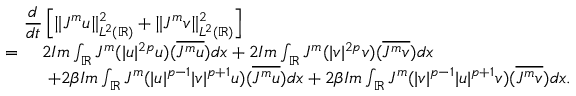<formula> <loc_0><loc_0><loc_500><loc_500>\begin{array} { r l } { { \frac { d } { d t } \left [ \| J ^ { m } u \| _ { L ^ { 2 } ( \mathbb { R } ) } ^ { 2 } + \| J ^ { m } v \| _ { L ^ { 2 } ( \mathbb { R } ) } ^ { 2 } \right ] } } \\ { = \ } & { 2 I m \int _ { \mathbb { R } } J ^ { m } ( | u | ^ { 2 p } u ) ( \overline { { J ^ { m } u } } ) d x + 2 I m \int _ { \mathbb { R } } J ^ { m } ( | v | ^ { 2 p } v ) ( \overline { { J ^ { m } v } } ) d x } \\ & { \ + 2 \beta I m \int _ { \mathbb { R } } J ^ { m } ( | u | ^ { p - 1 } | v | ^ { p + 1 } u ) ( \overline { { J ^ { m } u } } ) d x + 2 \beta I m \int _ { \mathbb { R } } J ^ { m } ( | v | ^ { p - 1 } | u | ^ { p + 1 } v ) ( \overline { { J ^ { m } v } } ) d x . } \end{array}</formula> 